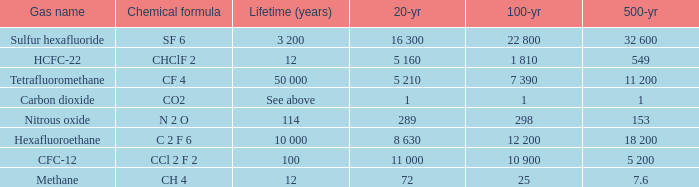What is the 100 year when 500 year is 153? 298.0. 